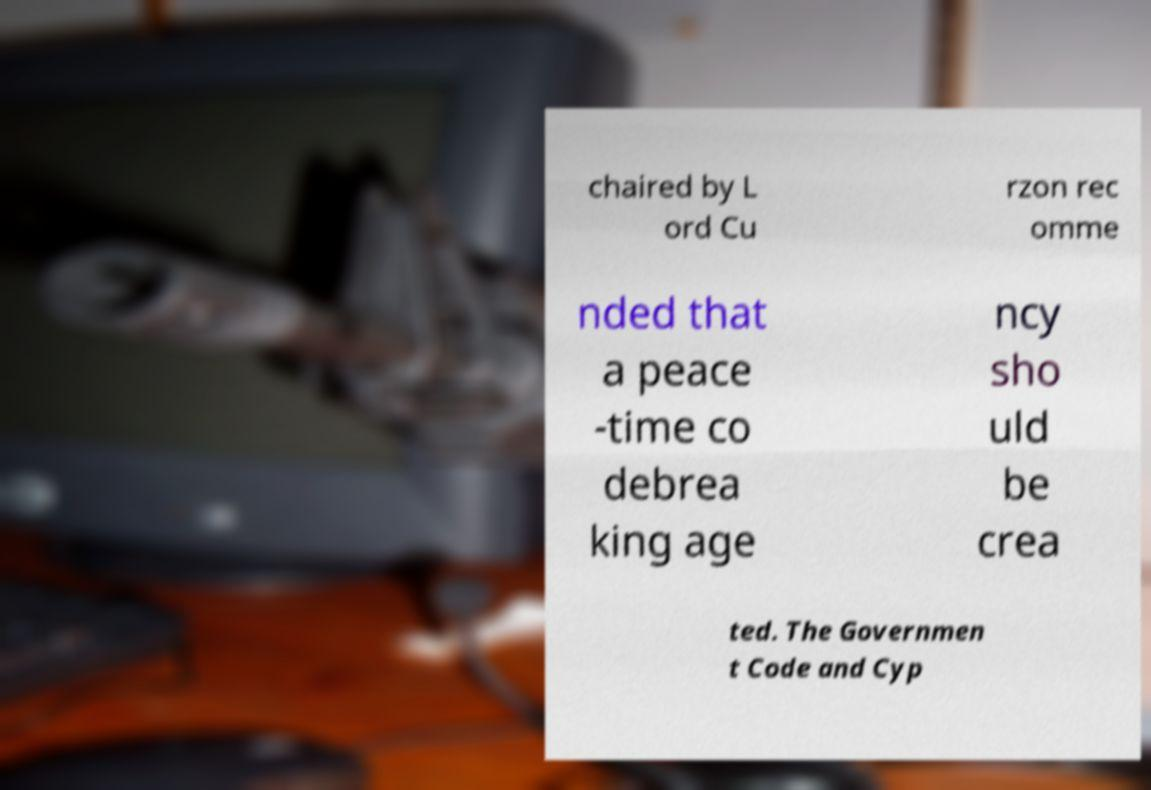Please read and relay the text visible in this image. What does it say? chaired by L ord Cu rzon rec omme nded that a peace -time co debrea king age ncy sho uld be crea ted. The Governmen t Code and Cyp 